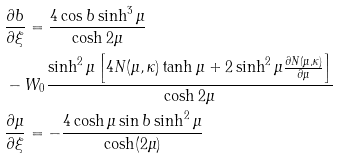<formula> <loc_0><loc_0><loc_500><loc_500>& \frac { \partial b } { \partial \xi } = \frac { 4 \cos b \sinh ^ { 3 } \mu } { \cosh 2 \mu } \\ & - W _ { 0 } \frac { \sinh ^ { 2 } \mu \left [ 4 N ( \mu , \kappa ) \tanh \mu + 2 \sinh ^ { 2 } \mu \frac { \partial N ( \mu , \kappa ) } { \partial \mu } \right ] } { \cosh 2 \mu } \\ & \frac { \partial \mu } { \partial \xi } = - \frac { 4 \cosh \mu \sin b \sinh ^ { 2 } \mu } { \cosh ( 2 \mu ) }</formula> 